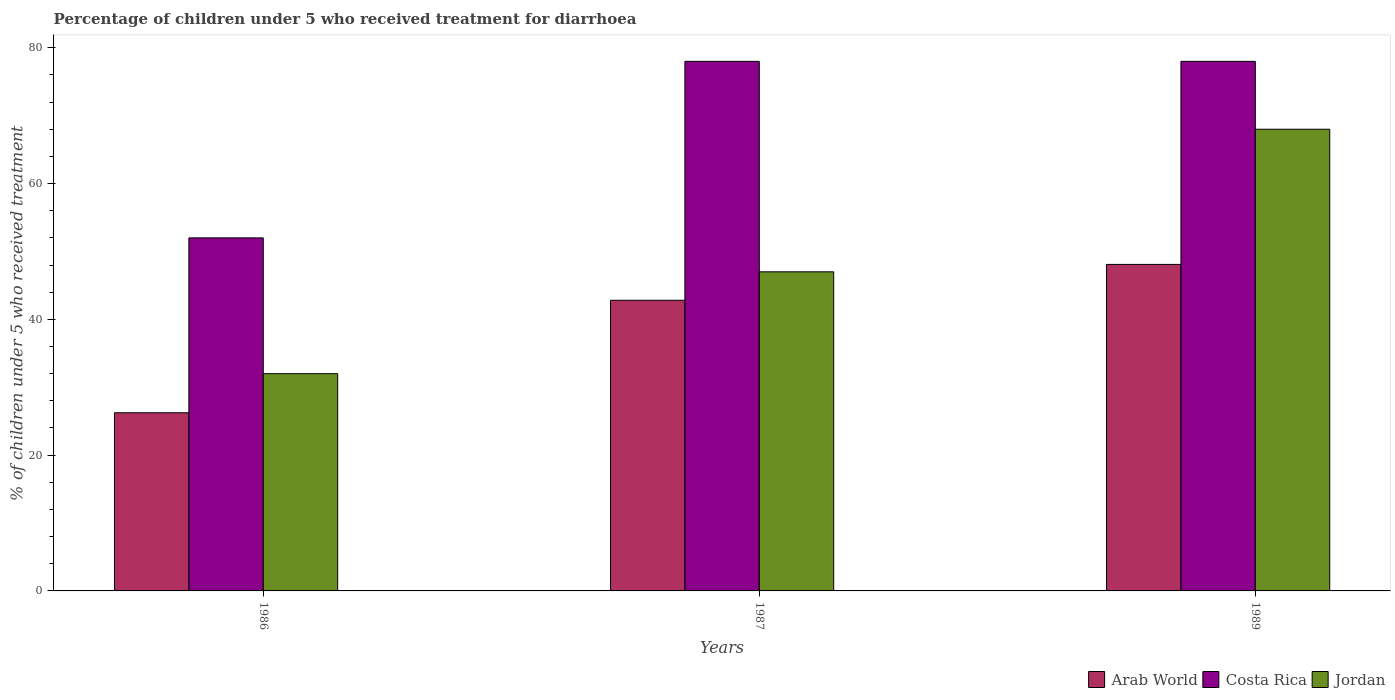How many different coloured bars are there?
Give a very brief answer. 3. How many groups of bars are there?
Provide a short and direct response. 3. How many bars are there on the 1st tick from the left?
Your answer should be very brief. 3. What is the label of the 2nd group of bars from the left?
Ensure brevity in your answer.  1987. In how many cases, is the number of bars for a given year not equal to the number of legend labels?
Make the answer very short. 0. Across all years, what is the minimum percentage of children who received treatment for diarrhoea  in Jordan?
Make the answer very short. 32. In which year was the percentage of children who received treatment for diarrhoea  in Arab World maximum?
Your answer should be very brief. 1989. What is the total percentage of children who received treatment for diarrhoea  in Costa Rica in the graph?
Provide a succinct answer. 208. What is the difference between the percentage of children who received treatment for diarrhoea  in Arab World in 1986 and that in 1989?
Your response must be concise. -21.85. What is the difference between the percentage of children who received treatment for diarrhoea  in Jordan in 1986 and the percentage of children who received treatment for diarrhoea  in Arab World in 1989?
Keep it short and to the point. -16.09. What is the average percentage of children who received treatment for diarrhoea  in Arab World per year?
Offer a terse response. 39.05. What is the ratio of the percentage of children who received treatment for diarrhoea  in Costa Rica in 1986 to that in 1989?
Your answer should be very brief. 0.67. Is the difference between the percentage of children who received treatment for diarrhoea  in Costa Rica in 1987 and 1989 greater than the difference between the percentage of children who received treatment for diarrhoea  in Jordan in 1987 and 1989?
Ensure brevity in your answer.  Yes. What is the difference between the highest and the lowest percentage of children who received treatment for diarrhoea  in Costa Rica?
Your response must be concise. 26. In how many years, is the percentage of children who received treatment for diarrhoea  in Arab World greater than the average percentage of children who received treatment for diarrhoea  in Arab World taken over all years?
Provide a succinct answer. 2. Is the sum of the percentage of children who received treatment for diarrhoea  in Arab World in 1986 and 1987 greater than the maximum percentage of children who received treatment for diarrhoea  in Jordan across all years?
Provide a short and direct response. Yes. What does the 1st bar from the left in 1987 represents?
Your response must be concise. Arab World. Does the graph contain any zero values?
Your response must be concise. No. Does the graph contain grids?
Provide a succinct answer. No. How many legend labels are there?
Offer a terse response. 3. What is the title of the graph?
Provide a short and direct response. Percentage of children under 5 who received treatment for diarrhoea. Does "Luxembourg" appear as one of the legend labels in the graph?
Your answer should be very brief. No. What is the label or title of the Y-axis?
Provide a short and direct response. % of children under 5 who received treatment. What is the % of children under 5 who received treatment of Arab World in 1986?
Give a very brief answer. 26.24. What is the % of children under 5 who received treatment of Arab World in 1987?
Offer a terse response. 42.81. What is the % of children under 5 who received treatment of Costa Rica in 1987?
Ensure brevity in your answer.  78. What is the % of children under 5 who received treatment in Jordan in 1987?
Make the answer very short. 47. What is the % of children under 5 who received treatment of Arab World in 1989?
Give a very brief answer. 48.09. What is the % of children under 5 who received treatment in Jordan in 1989?
Provide a succinct answer. 68. Across all years, what is the maximum % of children under 5 who received treatment of Arab World?
Provide a succinct answer. 48.09. Across all years, what is the minimum % of children under 5 who received treatment of Arab World?
Make the answer very short. 26.24. Across all years, what is the minimum % of children under 5 who received treatment of Costa Rica?
Keep it short and to the point. 52. Across all years, what is the minimum % of children under 5 who received treatment of Jordan?
Your answer should be compact. 32. What is the total % of children under 5 who received treatment of Arab World in the graph?
Give a very brief answer. 117.14. What is the total % of children under 5 who received treatment in Costa Rica in the graph?
Your answer should be very brief. 208. What is the total % of children under 5 who received treatment of Jordan in the graph?
Provide a short and direct response. 147. What is the difference between the % of children under 5 who received treatment in Arab World in 1986 and that in 1987?
Offer a terse response. -16.57. What is the difference between the % of children under 5 who received treatment in Jordan in 1986 and that in 1987?
Your response must be concise. -15. What is the difference between the % of children under 5 who received treatment of Arab World in 1986 and that in 1989?
Provide a short and direct response. -21.85. What is the difference between the % of children under 5 who received treatment in Costa Rica in 1986 and that in 1989?
Ensure brevity in your answer.  -26. What is the difference between the % of children under 5 who received treatment in Jordan in 1986 and that in 1989?
Provide a short and direct response. -36. What is the difference between the % of children under 5 who received treatment of Arab World in 1987 and that in 1989?
Provide a succinct answer. -5.28. What is the difference between the % of children under 5 who received treatment in Costa Rica in 1987 and that in 1989?
Give a very brief answer. 0. What is the difference between the % of children under 5 who received treatment in Arab World in 1986 and the % of children under 5 who received treatment in Costa Rica in 1987?
Make the answer very short. -51.76. What is the difference between the % of children under 5 who received treatment of Arab World in 1986 and the % of children under 5 who received treatment of Jordan in 1987?
Ensure brevity in your answer.  -20.76. What is the difference between the % of children under 5 who received treatment of Arab World in 1986 and the % of children under 5 who received treatment of Costa Rica in 1989?
Keep it short and to the point. -51.76. What is the difference between the % of children under 5 who received treatment in Arab World in 1986 and the % of children under 5 who received treatment in Jordan in 1989?
Give a very brief answer. -41.76. What is the difference between the % of children under 5 who received treatment in Costa Rica in 1986 and the % of children under 5 who received treatment in Jordan in 1989?
Give a very brief answer. -16. What is the difference between the % of children under 5 who received treatment of Arab World in 1987 and the % of children under 5 who received treatment of Costa Rica in 1989?
Ensure brevity in your answer.  -35.19. What is the difference between the % of children under 5 who received treatment of Arab World in 1987 and the % of children under 5 who received treatment of Jordan in 1989?
Give a very brief answer. -25.19. What is the average % of children under 5 who received treatment of Arab World per year?
Offer a very short reply. 39.05. What is the average % of children under 5 who received treatment of Costa Rica per year?
Keep it short and to the point. 69.33. In the year 1986, what is the difference between the % of children under 5 who received treatment in Arab World and % of children under 5 who received treatment in Costa Rica?
Your answer should be compact. -25.76. In the year 1986, what is the difference between the % of children under 5 who received treatment in Arab World and % of children under 5 who received treatment in Jordan?
Your response must be concise. -5.76. In the year 1986, what is the difference between the % of children under 5 who received treatment of Costa Rica and % of children under 5 who received treatment of Jordan?
Ensure brevity in your answer.  20. In the year 1987, what is the difference between the % of children under 5 who received treatment in Arab World and % of children under 5 who received treatment in Costa Rica?
Your answer should be very brief. -35.19. In the year 1987, what is the difference between the % of children under 5 who received treatment of Arab World and % of children under 5 who received treatment of Jordan?
Provide a succinct answer. -4.19. In the year 1987, what is the difference between the % of children under 5 who received treatment of Costa Rica and % of children under 5 who received treatment of Jordan?
Keep it short and to the point. 31. In the year 1989, what is the difference between the % of children under 5 who received treatment in Arab World and % of children under 5 who received treatment in Costa Rica?
Provide a short and direct response. -29.91. In the year 1989, what is the difference between the % of children under 5 who received treatment of Arab World and % of children under 5 who received treatment of Jordan?
Offer a terse response. -19.91. What is the ratio of the % of children under 5 who received treatment in Arab World in 1986 to that in 1987?
Offer a terse response. 0.61. What is the ratio of the % of children under 5 who received treatment of Jordan in 1986 to that in 1987?
Provide a short and direct response. 0.68. What is the ratio of the % of children under 5 who received treatment in Arab World in 1986 to that in 1989?
Give a very brief answer. 0.55. What is the ratio of the % of children under 5 who received treatment of Jordan in 1986 to that in 1989?
Offer a very short reply. 0.47. What is the ratio of the % of children under 5 who received treatment in Arab World in 1987 to that in 1989?
Ensure brevity in your answer.  0.89. What is the ratio of the % of children under 5 who received treatment of Jordan in 1987 to that in 1989?
Your answer should be compact. 0.69. What is the difference between the highest and the second highest % of children under 5 who received treatment in Arab World?
Make the answer very short. 5.28. What is the difference between the highest and the second highest % of children under 5 who received treatment of Costa Rica?
Keep it short and to the point. 0. What is the difference between the highest and the second highest % of children under 5 who received treatment in Jordan?
Your response must be concise. 21. What is the difference between the highest and the lowest % of children under 5 who received treatment in Arab World?
Your answer should be compact. 21.85. What is the difference between the highest and the lowest % of children under 5 who received treatment of Costa Rica?
Make the answer very short. 26. What is the difference between the highest and the lowest % of children under 5 who received treatment of Jordan?
Your response must be concise. 36. 